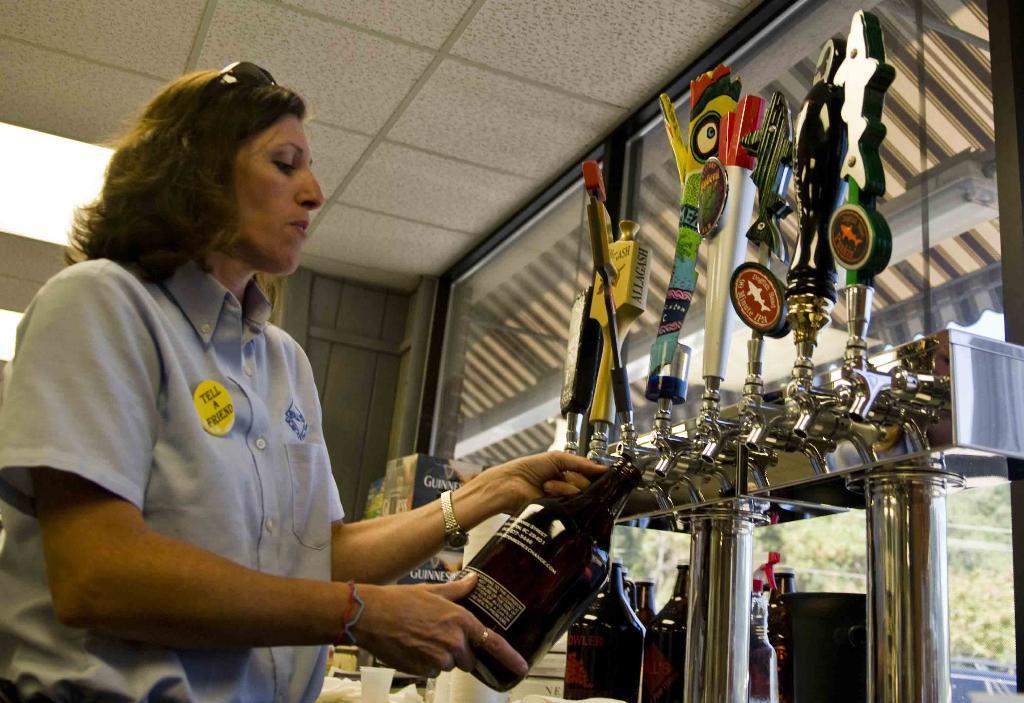Describe this image in one or two sentences. In this picture I can see a woman standing and holding bottle, in front I can see some taps to the tank. 